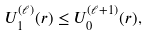Convert formula to latex. <formula><loc_0><loc_0><loc_500><loc_500>U ^ { ( \ell ) } _ { 1 } ( r ) \leq U ^ { ( \ell + 1 ) } _ { 0 } ( r ) ,</formula> 